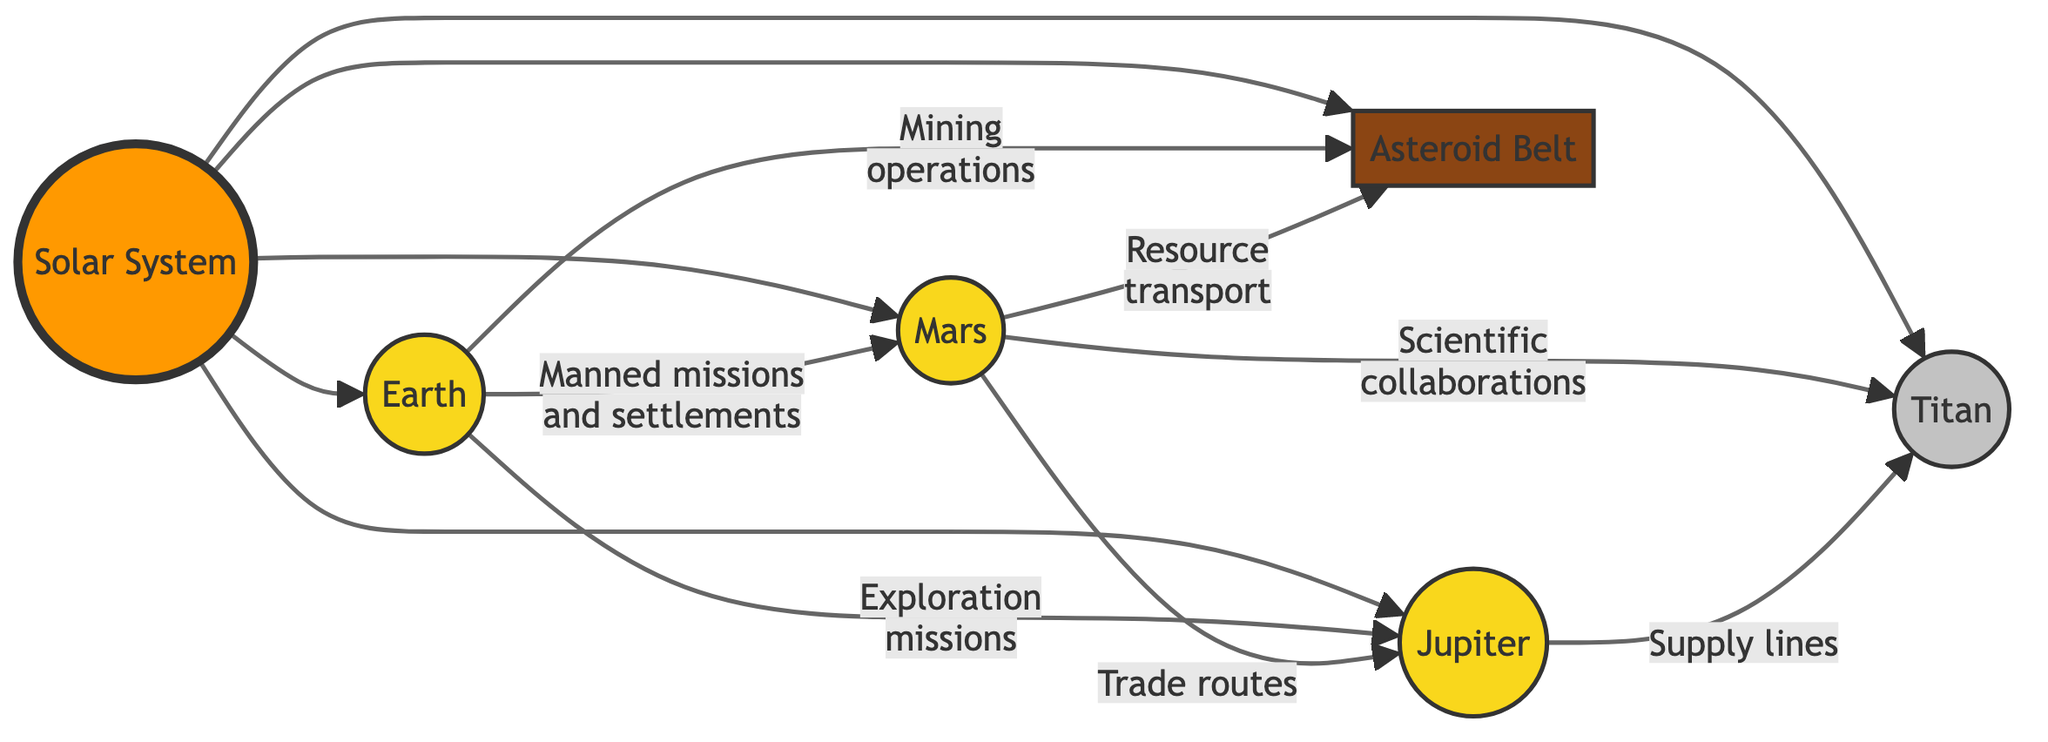What planet connects to Mars through "Manned missions and settlements"? The diagram shows that Earth directly connects to Mars with the relationship "Manned missions and settlements," indicating that Earth has a direct involvement in Mars through this specific mission type.
Answer: Earth What are the primary activities connecting Mars and Jupiter? The diagram illustrates that Mars connects to Jupiter through "Trade routes" and "Scientific collaborations," indicating multiple links in the context of trade and joint scientific efforts between these two planets.
Answer: Trade routes and Scientific collaborations How many celestial bodies are represented in the Solar System? The diagram counts one Solar System node, three planets (Earth, Mars, Jupiter), one moon (Titan), and one asteroid belt. This totals to five unique celestial bodies connected to the Solar System node.
Answer: 5 Which celestial body is associated with "Mining operations"? The diagram clearly indicates that Earth is associated with "Mining operations" in relation to the "Asteroid Belt," showing a specific task assigned to Earth within this context of resource extraction.
Answer: Earth What are the resources transported from Mars to the Asteroid Belt? The diagram specifically states that Mars is linked to the Asteroid Belt with "Resource transport," highlighting the logistical connection concerning resources moving from Mars to this particular asteroid collection.
Answer: Resource transport What type of relationship exists between Jupiter and Titan? The diagram defines the relationship between Jupiter and Titan as "Supply lines," indicating a logistical connection focused on the transfer or provision of supplies from Jupiter to Titan.
Answer: Supply lines How is Titan connected to Mars? Titan is shown to have a connection to Mars through "Scientific collaborations," which implies partnerships between entities on Mars and Titan related to scientific endeavors and research activities.
Answer: Scientific collaborations What kind of missions are depicted from Earth to Jupiter? The connection from Earth to Jupiter is labeled as "Exploration missions." This indicates that the relationship focuses on exploratory activities initiated from Earth targeted at Jupiter.
Answer: Exploration missions What is an unnamed celestial body in the diagram? The only unnamed body represented is the "Asteroid Belt," which the diagram refers to without a personal name like the planets or moon, but still signifies a distinct entity in the Solar System.
Answer: Asteroid Belt 